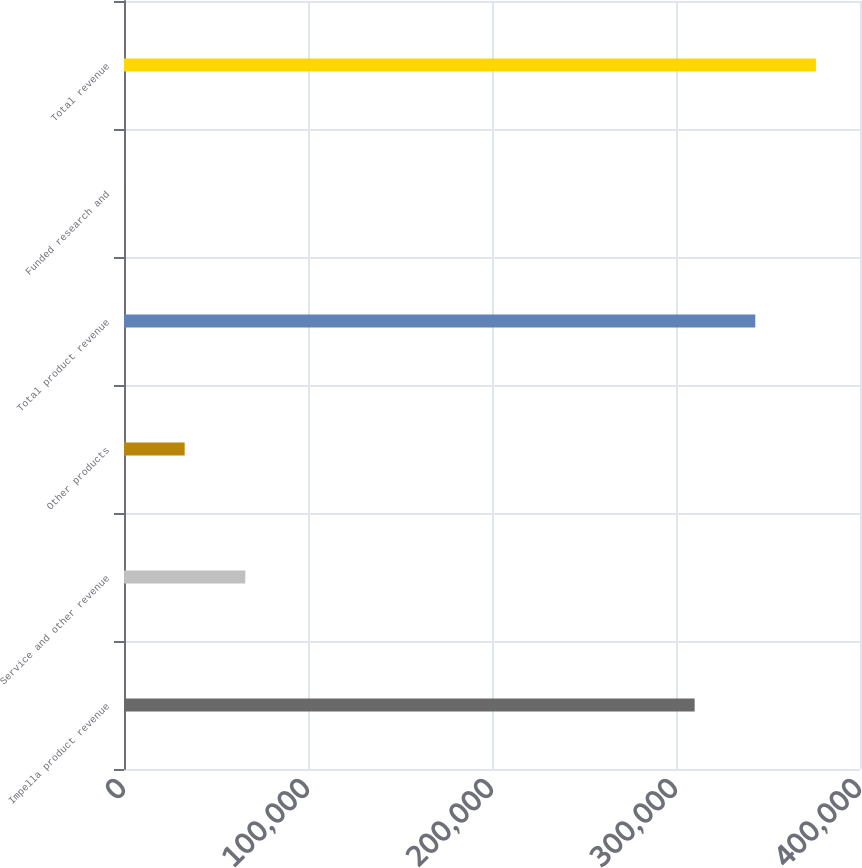<chart> <loc_0><loc_0><loc_500><loc_500><bar_chart><fcel>Impella product revenue<fcel>Service and other revenue<fcel>Other products<fcel>Total product revenue<fcel>Funded research and<fcel>Total revenue<nl><fcel>310138<fcel>65927<fcel>32975<fcel>343090<fcel>23<fcel>376042<nl></chart> 